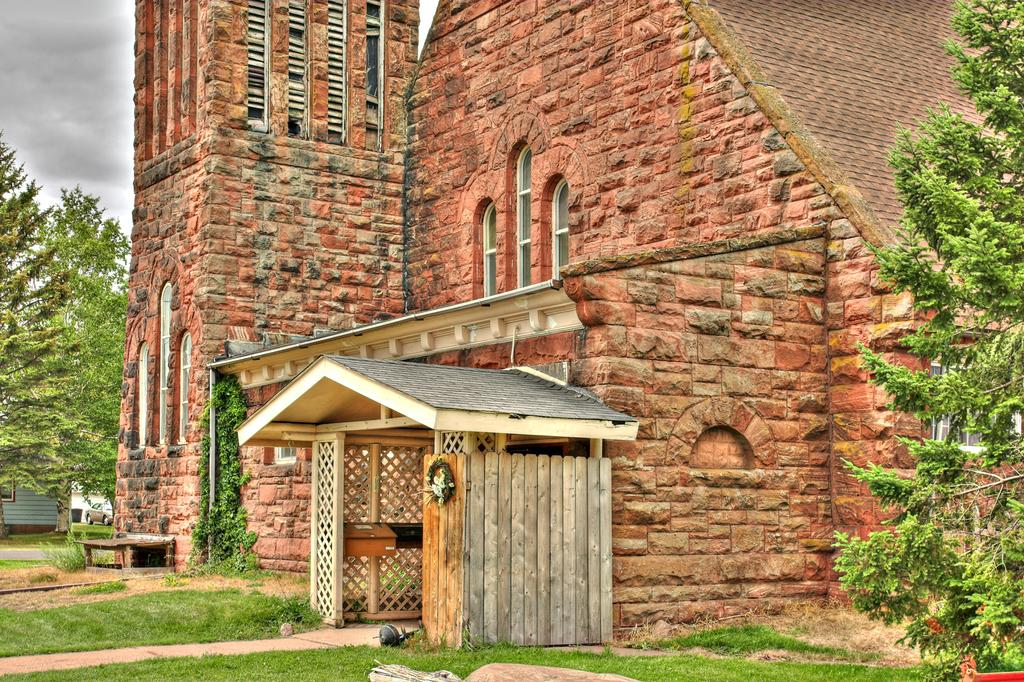What type of structure can be seen in the image? There is a building in the image. What natural elements are present in the image? There are trees, plants, grass, and the sky visible in the image. What man-made objects can be seen in the image? There are poles and a bench in the image. What material is used for the bench? The bench is made of wood, as indicated by the fact that there is wood in the image. Can you see any toys on the stage in the image? There is no stage or toys present in the image. Does the mist create a mysterious atmosphere in the image? There is no mist present in the image, so it cannot create any atmosphere. 